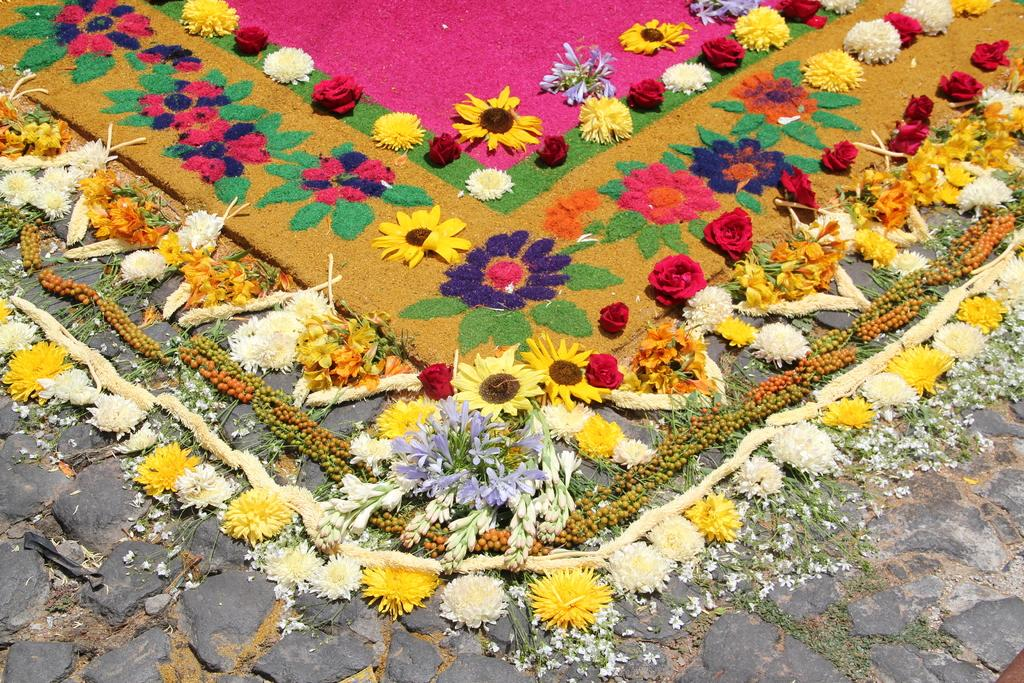What type of path is visible in the image? There is a rock path in the image. What is located near the rock path? There is a mat in the image. How is the mat decorated? The mat is decorated with flowers. Are there any flowers visible besides those on the mat? Yes, flowers are present around the mat. Can you see a robin perched on the flowers around the mat in the image? There is no robin present in the image. What impulse might have led to the creation of the flower-decorated mat in the image? The image does not provide information about the impulse or motivation behind the creation of the mat. 